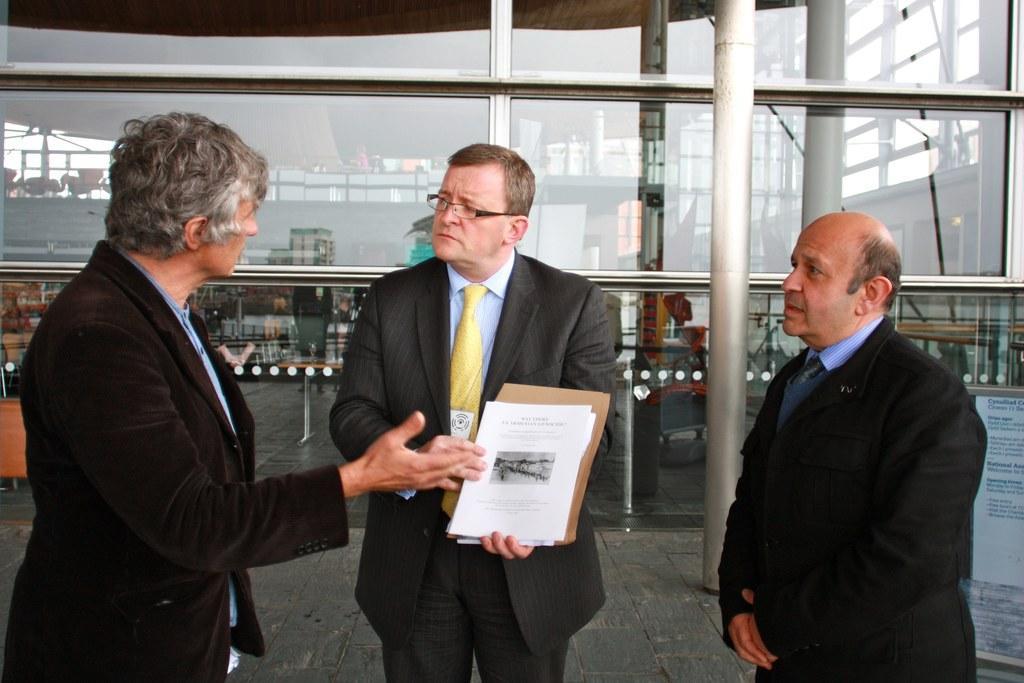In one or two sentences, can you explain what this image depicts? We can see three men are standing and the middle person is holding papers and a file in his hands. In the background there are glass doors, pole, hoarding board on the floor and through the glass doors we can see the objects. 